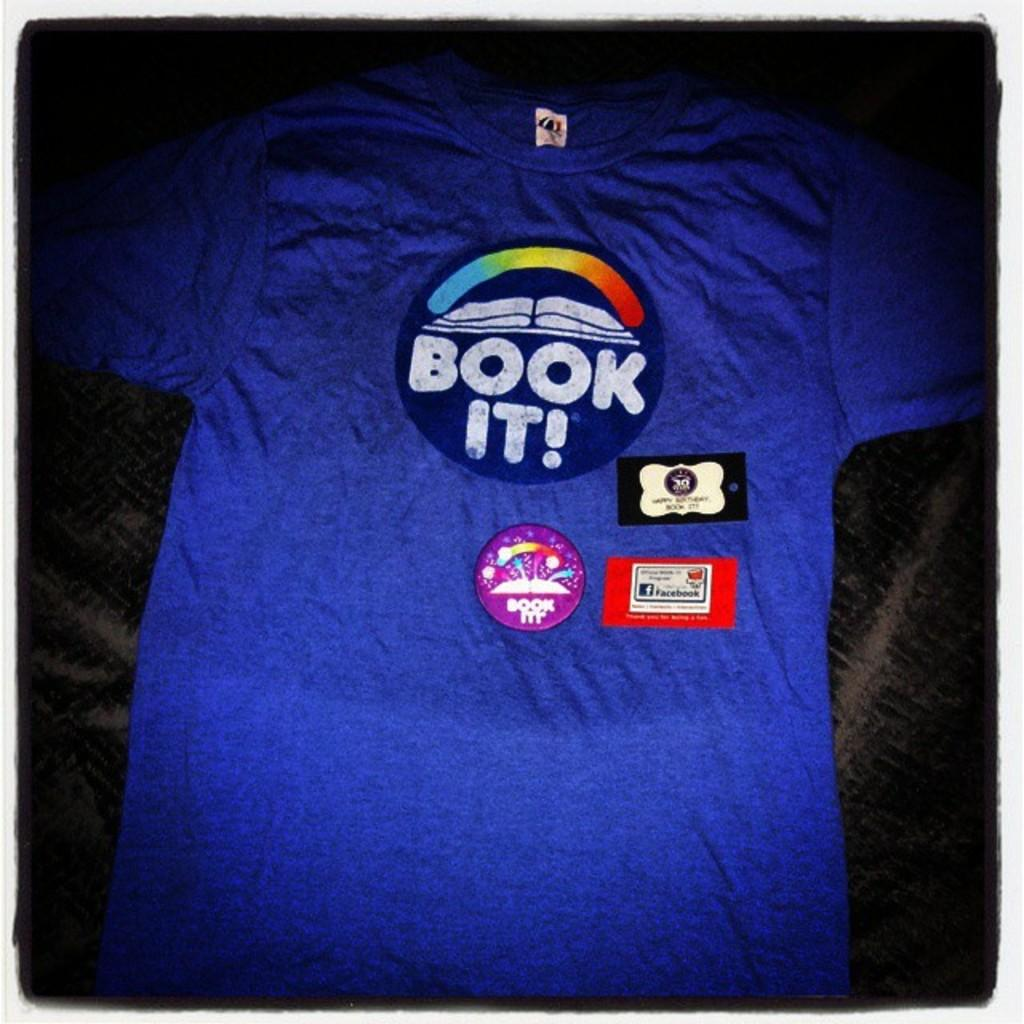What color is the t-shirt in the image? The t-shirt in the image is blue. What is written on the t-shirt? The words "Book it" are written on the t-shirt. What type of string is attached to the cat in the image? There is no cat present in the image, so there is no string attached to a cat. 